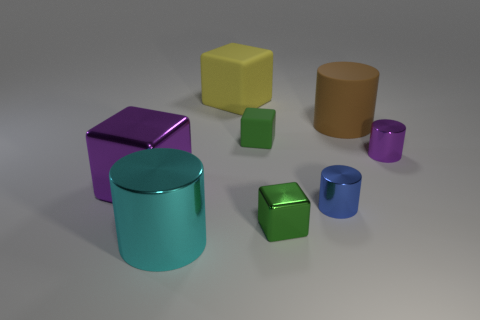How many objects are there in the image, and can you name their shapes? There are seven objects in the image, which include two cylinders, two cubes, two cuboids, and one cone-shaped object. Which of these shapes appears the most in the image? The cube shape appears most frequently, with two instances in the image. 